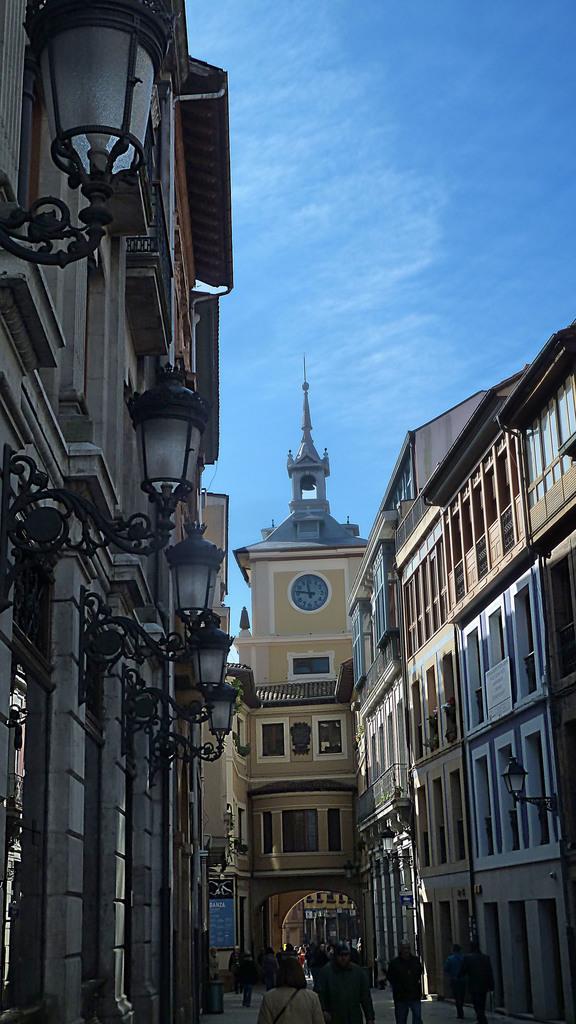Describe this image in one or two sentences. In the image I can see the buildings on the left side and the right side as well. I can see the decorative lamps on the wall. I can see a few people walking on the road at the bottom of the image. In the background, I can see a clock on the wall. There are clouds in the sky. 